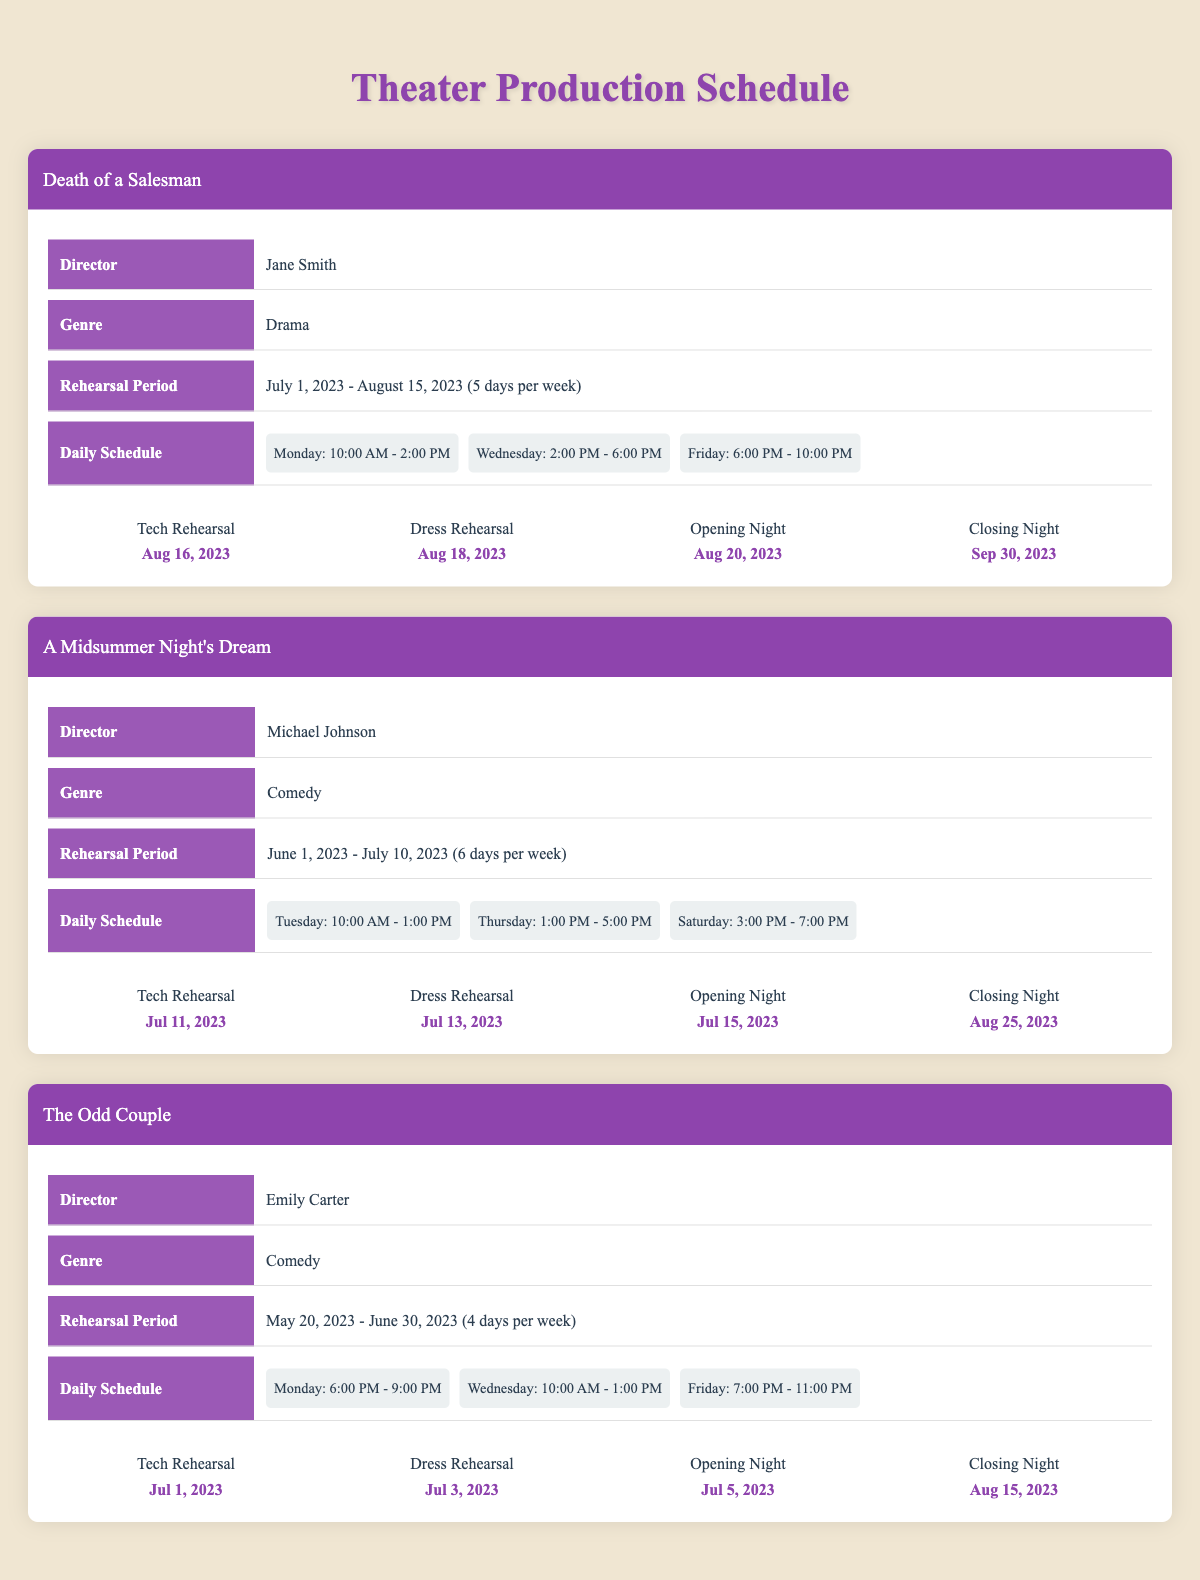What is the rehearsal schedule duration for "Death of a Salesman"? The rehearsal schedule for "Death of a Salesman" starts on July 1, 2023, and ends on August 15, 2023. To find the duration, count the days from the start date to the end date, which is 46 days.
Answer: 46 days Who is the director of "A Midsummer Night's Dream"? The table indicates that the director for "A Midsummer Night's Dream" is Michael Johnson.
Answer: Michael Johnson How many days per week are rehearsals scheduled for "The Odd Couple"? The rehearsal schedule for "The Odd Couple" specifies that rehearsals are scheduled 4 days per week.
Answer: 4 days Is "Death of a Salesman" a comedy? According to the genre listed in the table, "Death of a Salesman" is categorized as Drama, not Comedy. Thus, the answer is false.
Answer: No What is the gap between the Tech Rehearsal and Opening Night for "The Odd Couple"? "The Odd Couple" has its Tech Rehearsal on July 1, 2023, and its Opening Night on July 5, 2023. To find the gap, calculate the difference in days: July 5 minus July 1 equals 4 days.
Answer: 4 days Which production has the last Closing Night and when is it? The productions list their Closing Nights: "Death of a Salesman" on September 30, 2023, "A Midsummer Night's Dream" on August 25, 2023, and "The Odd Couple" on August 15, 2023. The last Closing Night is on September 30, 2023.
Answer: September 30, 2023 What is the average number of rehearsal days per week across all productions? The productions have varying days per week: "Death of a Salesman" has 5 days, "A Midsummer Night's Dream" has 6 days, and "The Odd Couple" has 4 days. To find the average: (5 + 6 + 4) / 3 = 5.
Answer: 5 Does "A Midsummer Night's Dream" start its rehearsal schedule after June 1, 2023? The start date for "A Midsummer Night's Dream" is June 1, 2023. Since the question is asking whether it starts after this date, the answer is false.
Answer: No What is the rehearsal time on Wednesdays for "Death of a Salesman"? The daily schedule shows that on Wednesdays for "Death of a Salesman," rehearsals are held from 2:00 PM to 6:00 PM.
Answer: 2:00 PM - 6:00 PM 